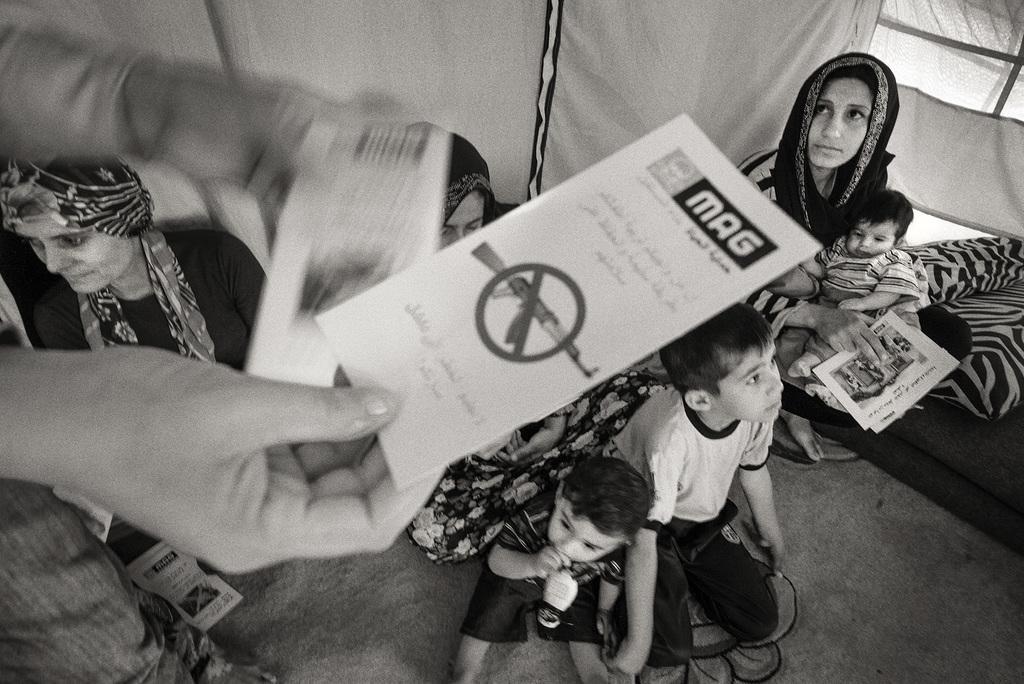In one or two sentences, can you explain what this image depicts? This image consists of few persons. In the front, we can see a person holding the papers. At the bottom, there is a floor. It looks like a tent. And we can see three children in this image. On the right, it looks like a bed. 